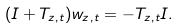<formula> <loc_0><loc_0><loc_500><loc_500>( I + T _ { z , t } ) w _ { z , t } = - T _ { z , t } I .</formula> 